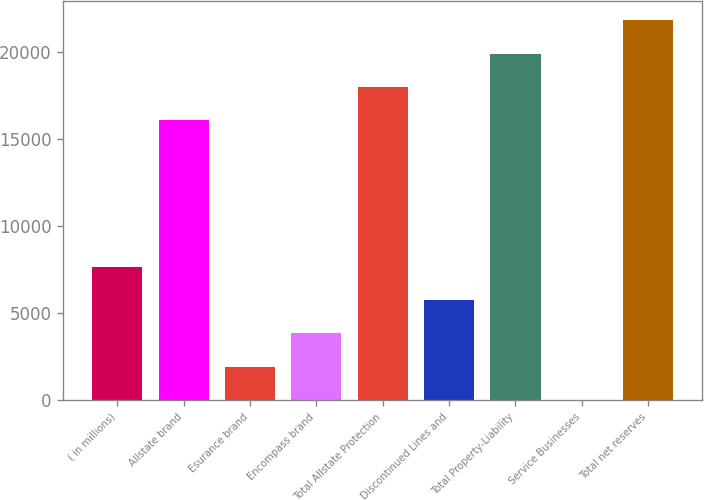Convert chart. <chart><loc_0><loc_0><loc_500><loc_500><bar_chart><fcel>( in millions)<fcel>Allstate brand<fcel>Esurance brand<fcel>Encompass brand<fcel>Total Allstate Protection<fcel>Discontinued Lines and<fcel>Total Property-Liability<fcel>Service Businesses<fcel>Total net reserves<nl><fcel>7640.8<fcel>16108<fcel>1928.2<fcel>3832.4<fcel>18012.2<fcel>5736.6<fcel>19916.4<fcel>24<fcel>21820.6<nl></chart> 